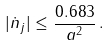Convert formula to latex. <formula><loc_0><loc_0><loc_500><loc_500>| \dot { n } _ { j } | \leq \frac { 0 . 6 8 3 } { a ^ { 2 } } \, .</formula> 